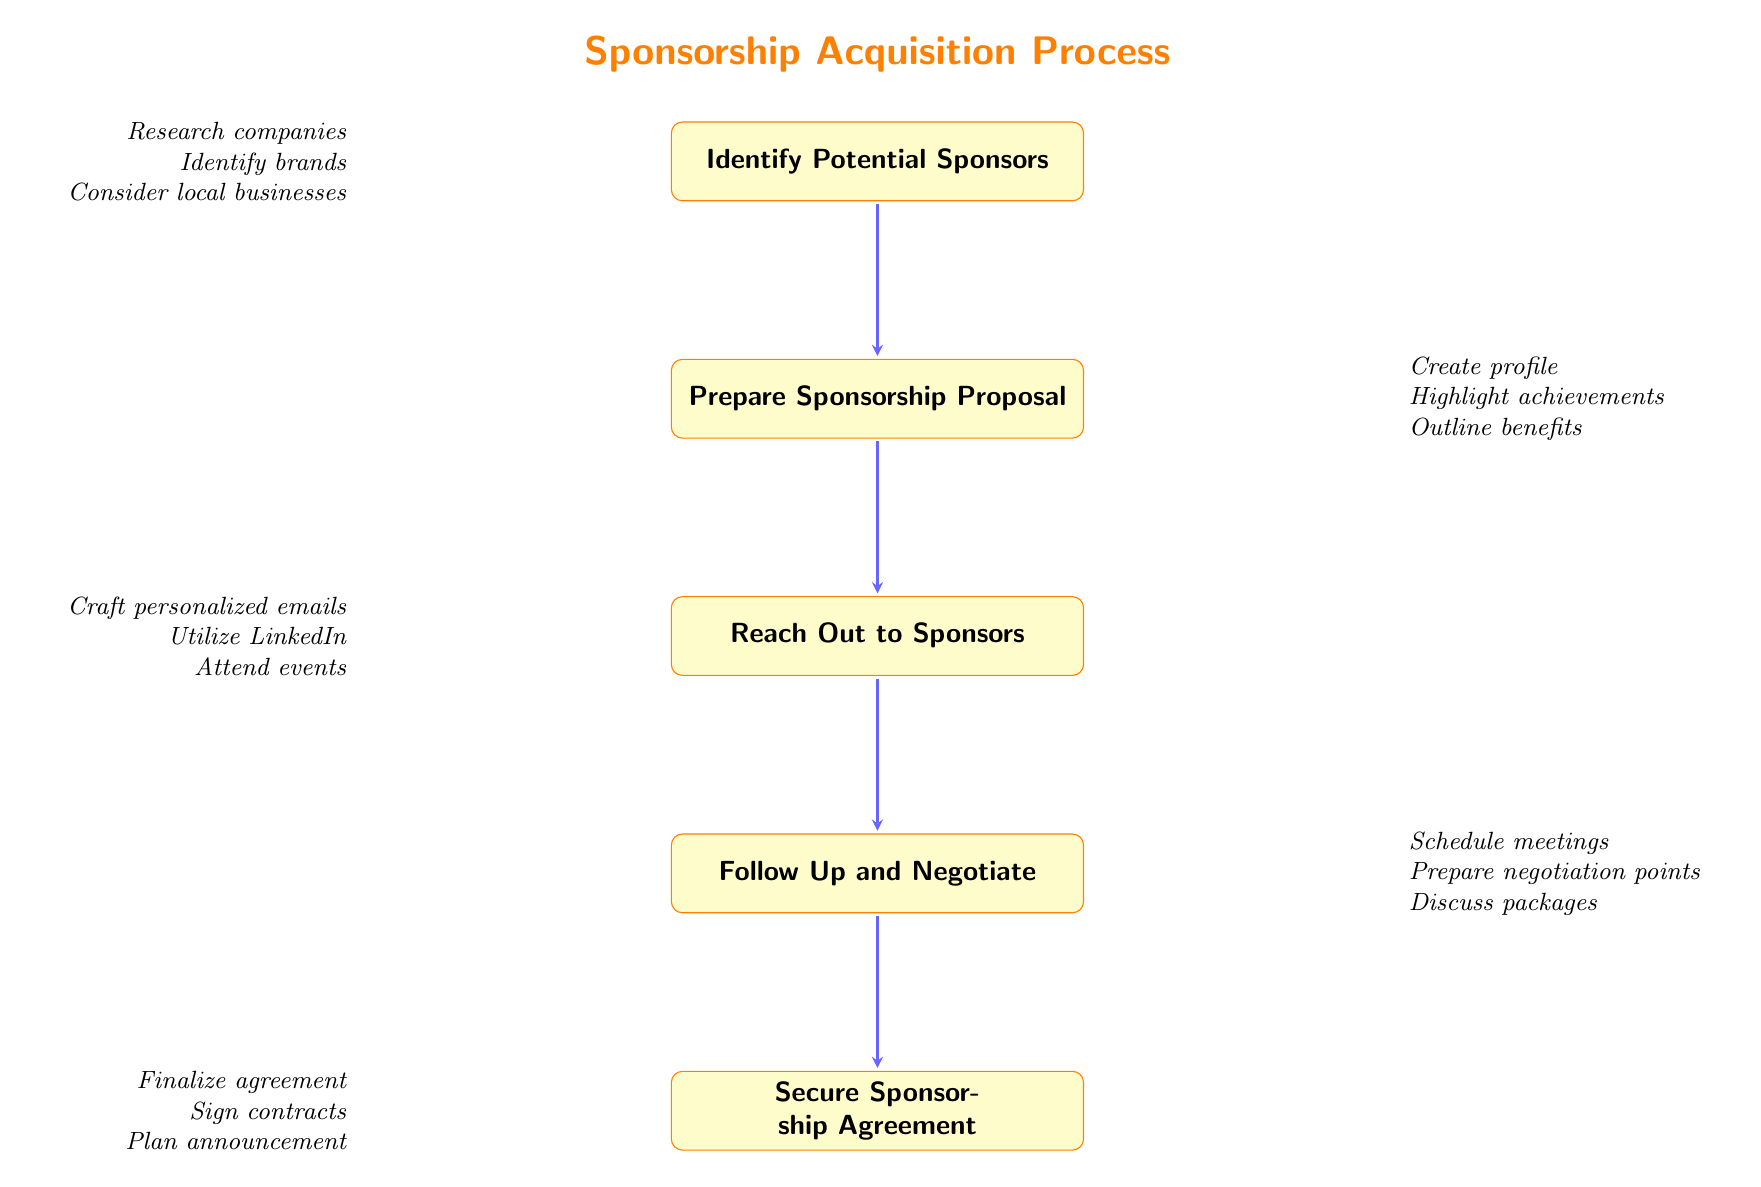What is the first step in the sponsorship acquisition process? The first step, as indicated by the top node in the diagram, is "Identify Potential Sponsors."
Answer: Identify Potential Sponsors How many total steps are there in the sponsorship acquisition process? There are five nodes in the diagram that represent different steps in the process: Identifying, Preparing, Reaching, Following Up, and Securing.
Answer: Five What process follows "Prepare Sponsorship Proposal"? The node directly beneath "Prepare Sponsorship Proposal" indicates that the next process is "Reach Out to Sponsors."
Answer: Reach Out to Sponsors Which step involves crafting personalized emails? The step that specifically mentions crafting personalized emails is "Reach Out to Sponsors."
Answer: Reach Out to Sponsors What is a key aspect of "Follow Up and Negotiate"? A key aspect mentioned in the details of "Follow Up and Negotiate" is "Prepare for Negotiation Points."
Answer: Prepare for Negotiation Points How does "Identify Potential Sponsors" relate to "Prepare Sponsorship Proposal"? "Identify Potential Sponsors" is the first step, and it directly leads into "Prepare Sponsorship Proposal" as the subsequent step in the flow.
Answer: Leads to Which two processes discuss agreements? The processes that involve agreements are "Follow Up and Negotiate" and "Secure Sponsorship Agreement."
Answer: Follow Up and Negotiate, Secure Sponsorship Agreement What should be included when preparing a sponsorship proposal? One of the key details to include in the sponsorship proposal is "Outline Benefits for Sponsors."
Answer: Outline Benefits for Sponsors What does the last process in the flow chart involve? The last process "Secure Sponsorship Agreement" involves finalizing agreement details and signing contracts, as detailed in the related points.
Answer: Finalize Agreement Details What is the main purpose of the "Sponsorship Acquisition Process" diagram? The main purpose of the diagram is to outline the step-by-step approach to securing sponsorships for a tennis player.
Answer: Outline Sponsorship Steps 